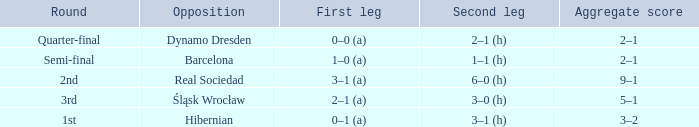What was the first leg of the semi-final? 1–0 (a). 